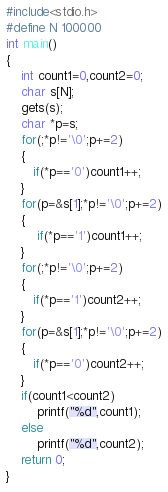<code> <loc_0><loc_0><loc_500><loc_500><_C_>#include<stdio.h>
#define N 100000
int main()
{
    int count1=0,count2=0;
    char s[N];
    gets(s);
    char *p=s;
    for(;*p!='\0';p+=2)
    {
       if(*p=='0')count1++;
    }
    for(p=&s[1];*p!='\0';p+=2)
    {
        if(*p=='1')count1++;
    }
    for(;*p!='\0';p+=2)
    {
       if(*p=='1')count2++;
    }
    for(p=&s[1];*p!='\0';p+=2)
    {
       if(*p=='0')count2++;
    }
    if(count1<count2)
        printf("%d",count1);
    else
        printf("%d",count2);
    return 0;
}
</code> 